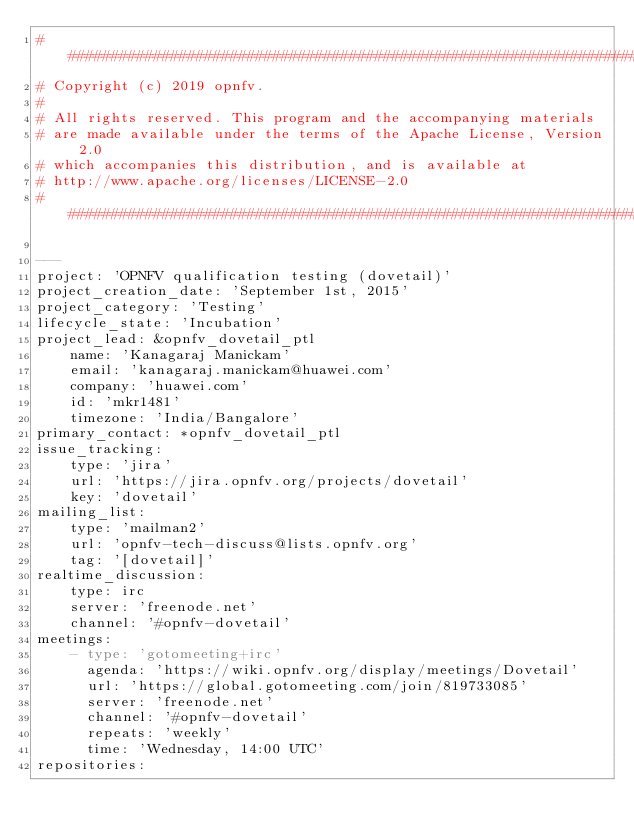Convert code to text. <code><loc_0><loc_0><loc_500><loc_500><_YAML_>##############################################################################
# Copyright (c) 2019 opnfv.
#
# All rights reserved. This program and the accompanying materials
# are made available under the terms of the Apache License, Version 2.0
# which accompanies this distribution, and is available at
# http://www.apache.org/licenses/LICENSE-2.0
##############################################################################

---
project: 'OPNFV qualification testing (dovetail)'
project_creation_date: 'September 1st, 2015'
project_category: 'Testing'
lifecycle_state: 'Incubation'
project_lead: &opnfv_dovetail_ptl
    name: 'Kanagaraj Manickam'
    email: 'kanagaraj.manickam@huawei.com'
    company: 'huawei.com'
    id: 'mkr1481'
    timezone: 'India/Bangalore'
primary_contact: *opnfv_dovetail_ptl
issue_tracking:
    type: 'jira'
    url: 'https://jira.opnfv.org/projects/dovetail'
    key: 'dovetail'
mailing_list:
    type: 'mailman2'
    url: 'opnfv-tech-discuss@lists.opnfv.org'
    tag: '[dovetail]'
realtime_discussion:
    type: irc
    server: 'freenode.net'
    channel: '#opnfv-dovetail'
meetings:
    - type: 'gotomeeting+irc'
      agenda: 'https://wiki.opnfv.org/display/meetings/Dovetail'
      url: 'https://global.gotomeeting.com/join/819733085'
      server: 'freenode.net'
      channel: '#opnfv-dovetail'
      repeats: 'weekly'
      time: 'Wednesday, 14:00 UTC'
repositories:</code> 